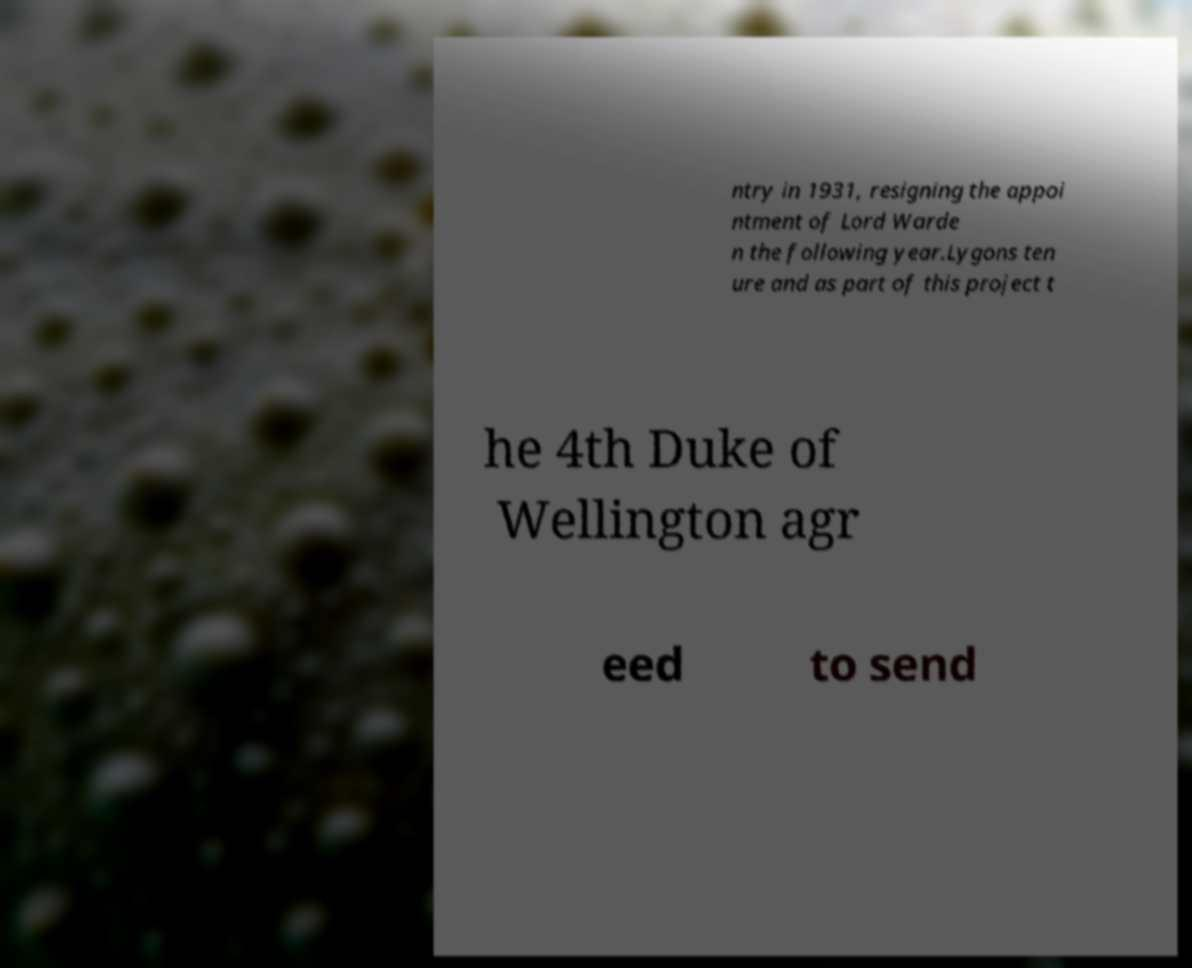Can you read and provide the text displayed in the image?This photo seems to have some interesting text. Can you extract and type it out for me? ntry in 1931, resigning the appoi ntment of Lord Warde n the following year.Lygons ten ure and as part of this project t he 4th Duke of Wellington agr eed to send 